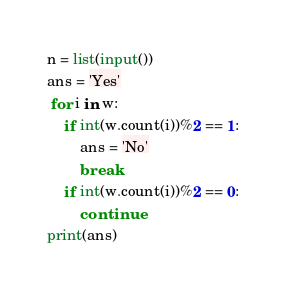Convert code to text. <code><loc_0><loc_0><loc_500><loc_500><_Python_>n = list(input())
ans = 'Yes'
 for i in w:
	if int(w.count(i))%2 == 1:
		ans = 'No'
		break
	if int(w.count(i))%2 == 0:
		continue
print(ans)</code> 